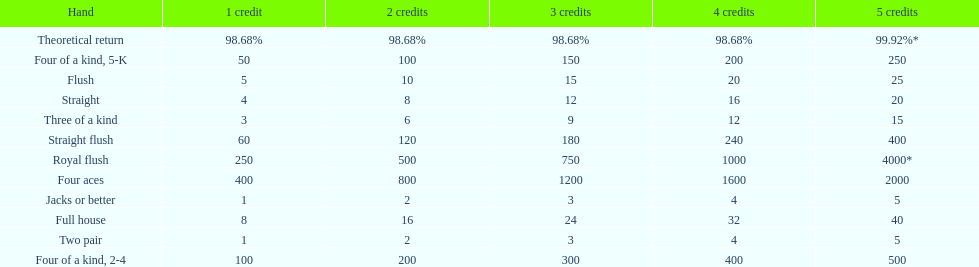The number of credits returned for a one credit bet on a royal flush are. 250. 